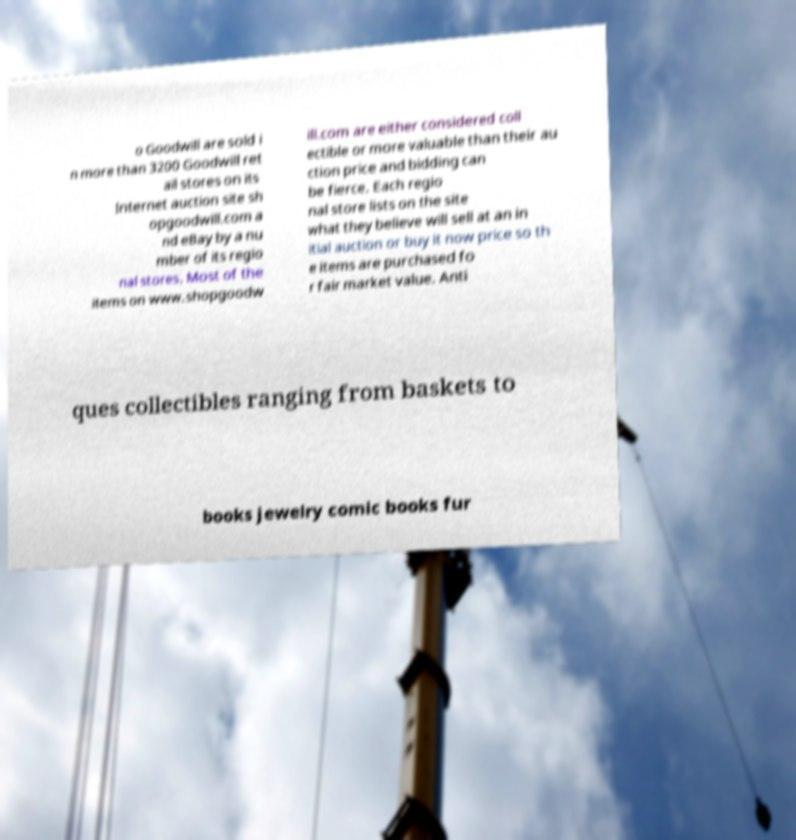Please identify and transcribe the text found in this image. o Goodwill are sold i n more than 3200 Goodwill ret ail stores on its Internet auction site sh opgoodwill.com a nd eBay by a nu mber of its regio nal stores. Most of the items on www.shopgoodw ill.com are either considered coll ectible or more valuable than their au ction price and bidding can be fierce. Each regio nal store lists on the site what they believe will sell at an in itial auction or buy it now price so th e items are purchased fo r fair market value. Anti ques collectibles ranging from baskets to books jewelry comic books fur 